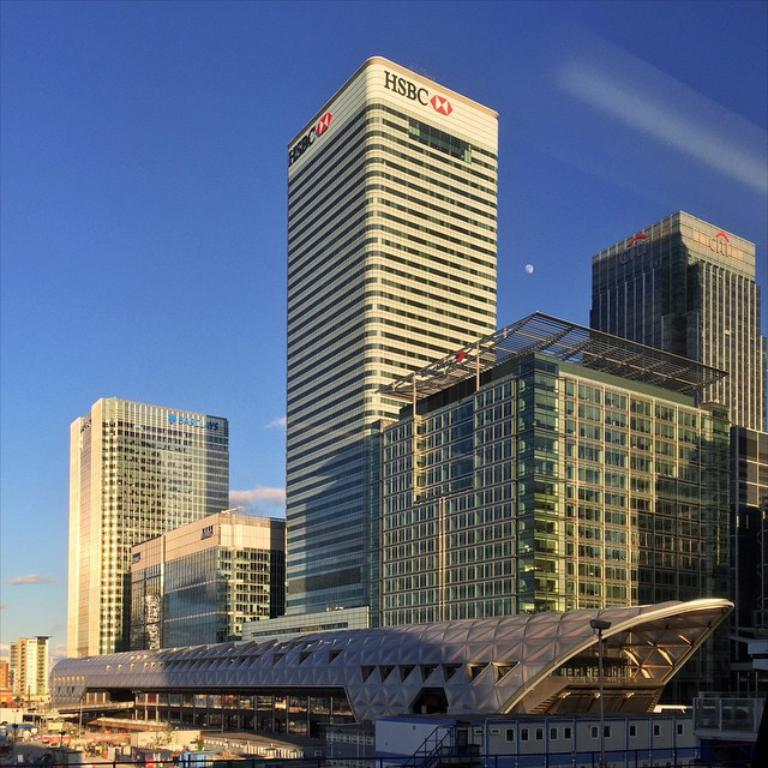What type of structures are present in the image? The image contains buildings and skyscrapers. Can you describe any other structures in the image? Yes, there is a shed at the bottom of the image. What can be seen in the sky in the image? The sky is visible at the top of the image. What arithmetic problem is being solved on the stage in the image? There is no stage or arithmetic problem present in the image. 